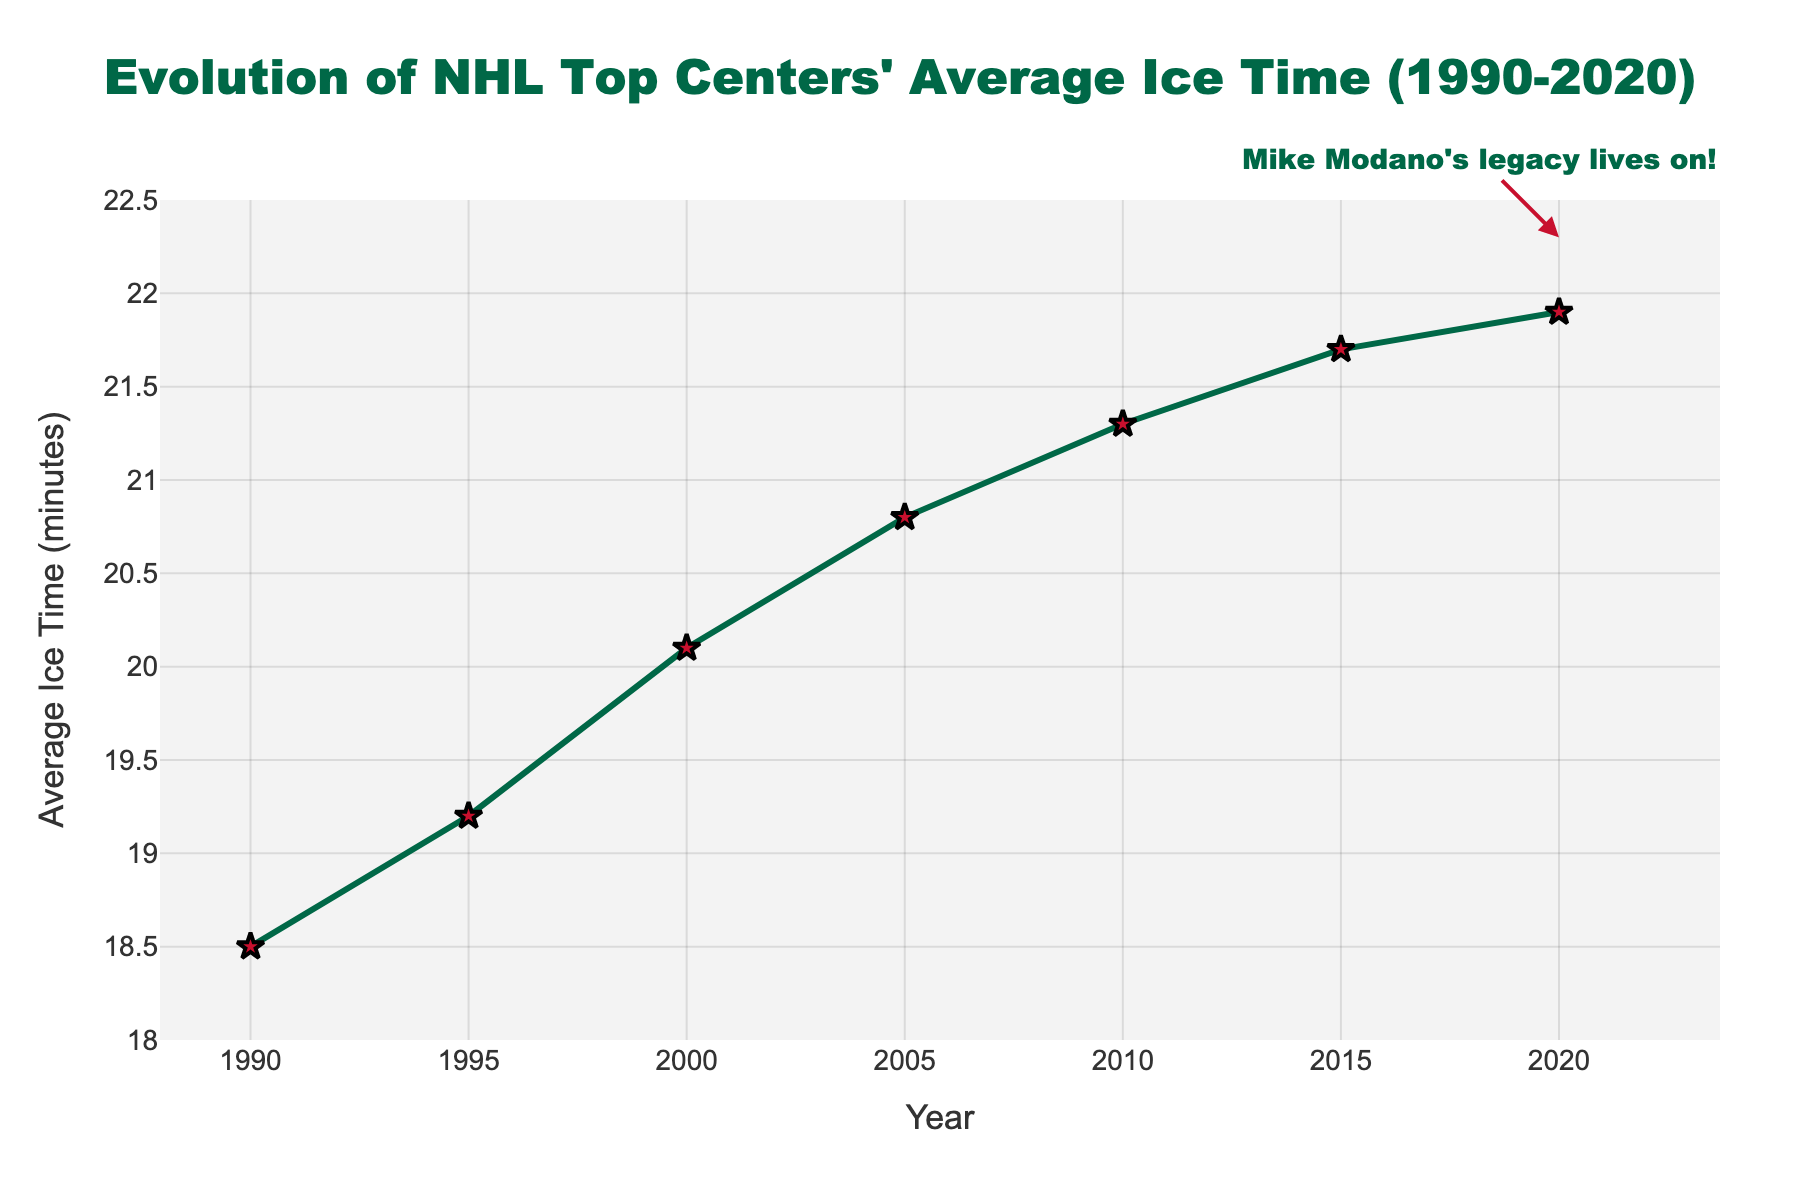How much did the average ice time increase from 1990 to 2020? First, identify the respective average ice times for 1990 (18.5 minutes) and 2020 (21.9 minutes). Then, subtract the 1990 value from the 2020 value: 21.9 - 18.5 = 3.4 minutes.
Answer: 3.4 minutes What was the average ice time in 2010 compared to 2000? Locate the average ice times for both 2010 (21.3 minutes) and 2000 (20.1 minutes). Then, subtract the 2000 value from the 2010 value: 21.3 - 20.1 = 1.2 minutes.
Answer: 1.2 minutes In which five-year interval did the average ice time increase the most? Compare the increase in average ice time for each five-year interval: 1990-1995 (19.2 - 18.5 = 0.7), 1995-2000 (20.1 - 19.2 = 0.9), 2000-2005 (20.8 - 20.1 = 0.7), 2005-2010 (21.3 - 20.8 = 0.5), 2010-2015 (21.7 - 21.3 = 0.4), 2015-2020 (21.9 - 21.7 = 0.2). The largest increase is between 1995 and 2000 with an increase of 0.9 minutes.
Answer: 1995-2000 How does the year 2000's average ice time compare visually to the year 2020's in terms of marker style? Observe the marks on the graph for both years. In 2000, the marker style is a star inside a red outline, and similarly, in 2020, it’s the same star marker. This consistency represents both using the same visual style, indicating key points.
Answer: Same marker style What is the average increase in ice time per decade from 1990 to 2020? Calculate the individual decade increases: 1990-2000 (20.1 - 18.5 = 1.6), 2000-2010 (21.3 - 20.1 = 1.2), 2010-2020 (21.9 - 21.3 = 0.6). Then, find the average increase per decade: (1.6 + 1.2 + 0.6) / 3 ≈ 1.13 minutes per decade.
Answer: Approximately 1.13 minutes per decade Which year had an average ice time closest to 21 minutes? Identify the years where average ice time is measured and select the closest value to 21 minutes. The values are 20.8 minutes in 2005 and 21.3 minutes in 2010, so 21.3 (from 2010) is more proximate to 21 minutes.
Answer: 2010 What was the average ice time for top centers in 2015, and how did it compare to the previous year with the largest increase? The average ice time in 2015 was 21.7 minutes. From the previous significant increase noted (1995-2000, a 0.9-minute increase), check the difference: 21.7 - 20.1 = 1.6 minutes ​increase from 2000.
Answer: 21.7 minutes compared to 1.6 minutes increase How many times did the average ice time rise above 21 minutes between 1990 and 2020? Check the provided data points for times the ice time value is greater than 21 minutes: this appears in 2010 (21.3), 2015 (21.7), and 2020 (21.9). This occurs three times.
Answer: 3 times What textual annotation is displayed on the plot and where is it located? Identify the text annotation and its placement on the graph: the text reads "Mike Modano's legacy lives on!" with an arrow pointing towards the data point for the year 2020.
Answer: "Mike Modano's legacy lives on!" near 2020 